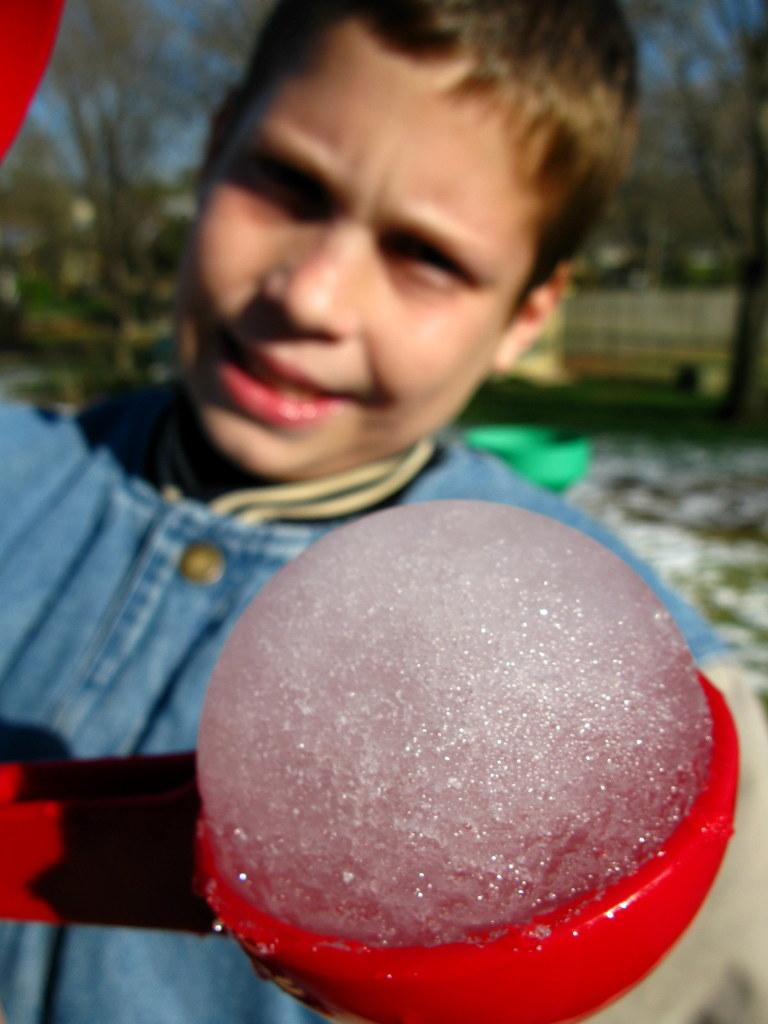What is the main subject of the image? There is a person in the center of the image. What is the person holding in the image? The person is holding an object. What can be seen in the background of the image? There are trees and buildings in the background of the image. What type of berry is being advertised in the image? There is no berry or advertisement present in the image. Is there any poison visible in the image? There is no poison present in the image. 